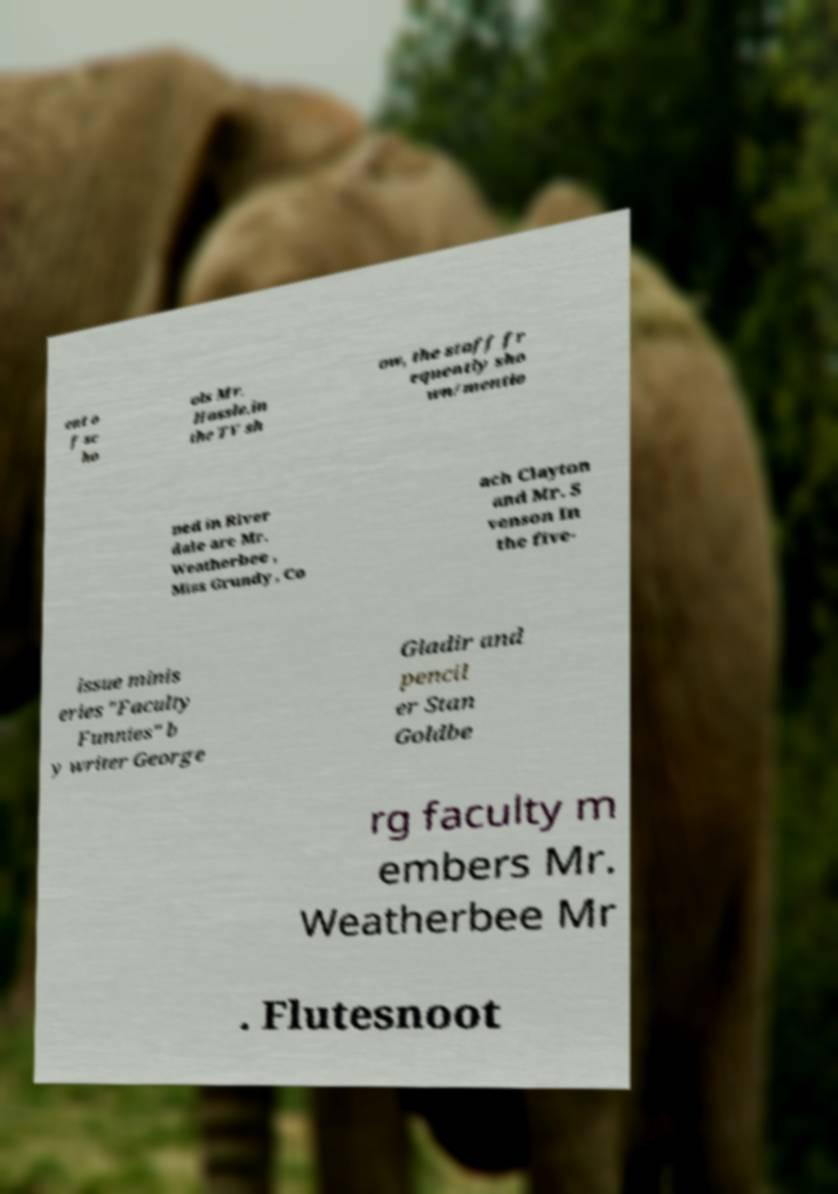What messages or text are displayed in this image? I need them in a readable, typed format. ent o f sc ho ols Mr. Hassle.in the TV sh ow, the staff fr equently sho wn/mentio ned in River dale are Mr. Weatherbee , Miss Grundy , Co ach Clayton and Mr. S venson In the five- issue minis eries "Faculty Funnies" b y writer George Gladir and pencil er Stan Goldbe rg faculty m embers Mr. Weatherbee Mr . Flutesnoot 